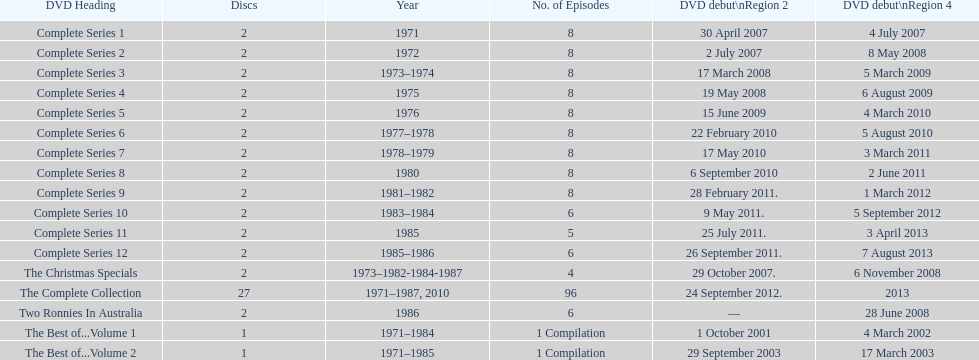What comes immediately after complete series 11? Complete Series 12. 